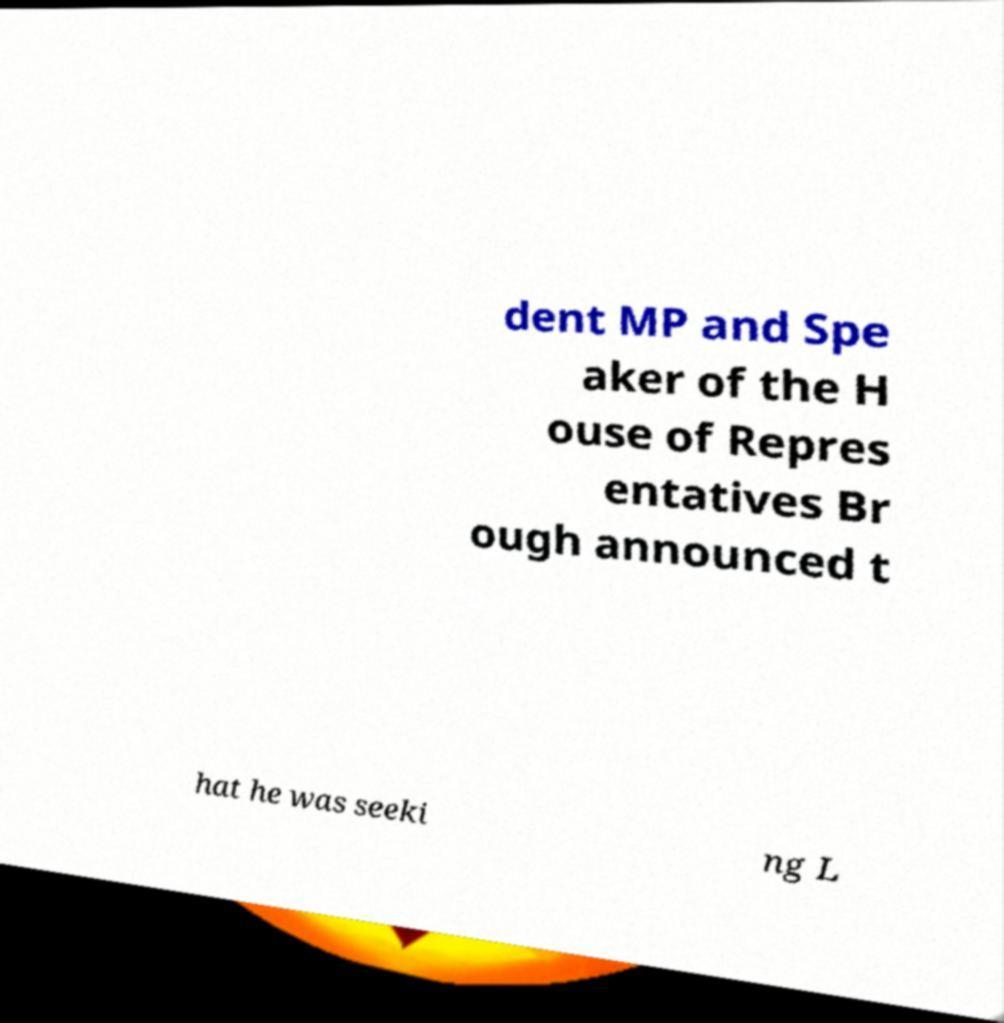For documentation purposes, I need the text within this image transcribed. Could you provide that? dent MP and Spe aker of the H ouse of Repres entatives Br ough announced t hat he was seeki ng L 